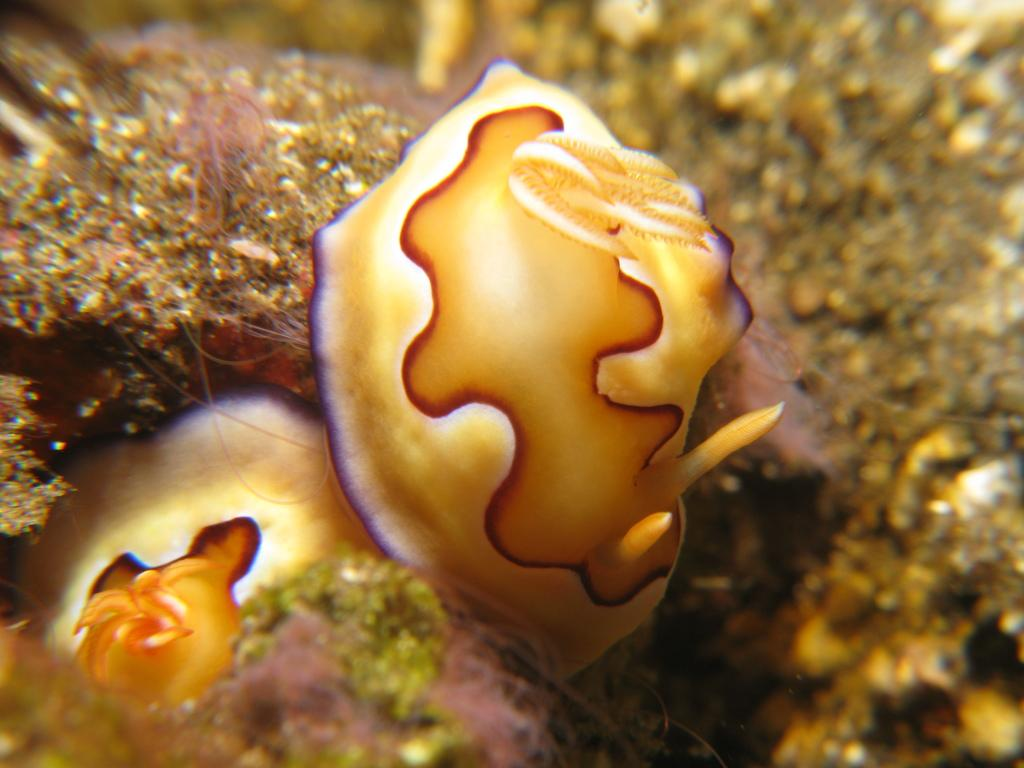What types of creatures are present in the image? There are two sea animals in the image. What can be seen on the ground in the image? There is moss on the ground in the image. How would you describe the background of the image? The background of the image is blurred. How many people are in the crowd in the image? There is no crowd present in the image; it features two sea animals and moss on the ground. What type of frog can be seen hopping on the moss in the image? There is no frog present in the image; it features two sea animals and moss on the ground. 